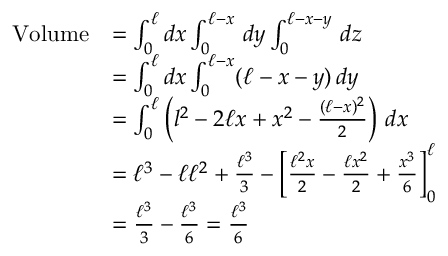<formula> <loc_0><loc_0><loc_500><loc_500>{ \begin{array} { r l } { V o l u m e } & { = \int _ { 0 } ^ { \ell } d x \int _ { 0 } ^ { \ell - x } \, d y \int _ { 0 } ^ { \ell - x - y } \, d z } \\ & { = \int _ { 0 } ^ { \ell } d x \int _ { 0 } ^ { \ell - x } ( \ell - x - y ) \, d y } \\ & { = \int _ { 0 } ^ { \ell } \left ( l ^ { 2 } - 2 \ell x + x ^ { 2 } - { \frac { ( \ell - x ) ^ { 2 } } { 2 } } \right ) \, d x } \\ & { = \ell ^ { 3 } - \ell \ell ^ { 2 } + { \frac { \ell ^ { 3 } } { 3 } } - \left [ { \frac { \ell ^ { 2 } x } { 2 } } - { \frac { \ell x ^ { 2 } } { 2 } } + { \frac { x ^ { 3 } } { 6 } } \right ] _ { 0 } ^ { \ell } } \\ & { = { \frac { \ell ^ { 3 } } { 3 } } - { \frac { \ell ^ { 3 } } { 6 } } = { \frac { \ell ^ { 3 } } { 6 } } } \end{array} }</formula> 